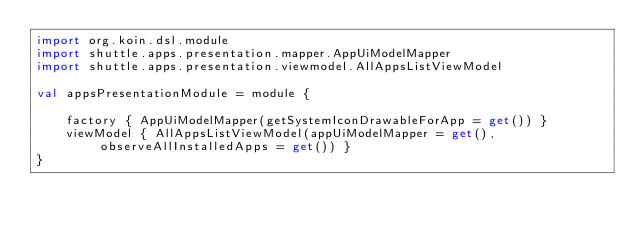<code> <loc_0><loc_0><loc_500><loc_500><_Kotlin_>import org.koin.dsl.module
import shuttle.apps.presentation.mapper.AppUiModelMapper
import shuttle.apps.presentation.viewmodel.AllAppsListViewModel

val appsPresentationModule = module {

    factory { AppUiModelMapper(getSystemIconDrawableForApp = get()) }
    viewModel { AllAppsListViewModel(appUiModelMapper = get(), observeAllInstalledApps = get()) }
}
</code> 